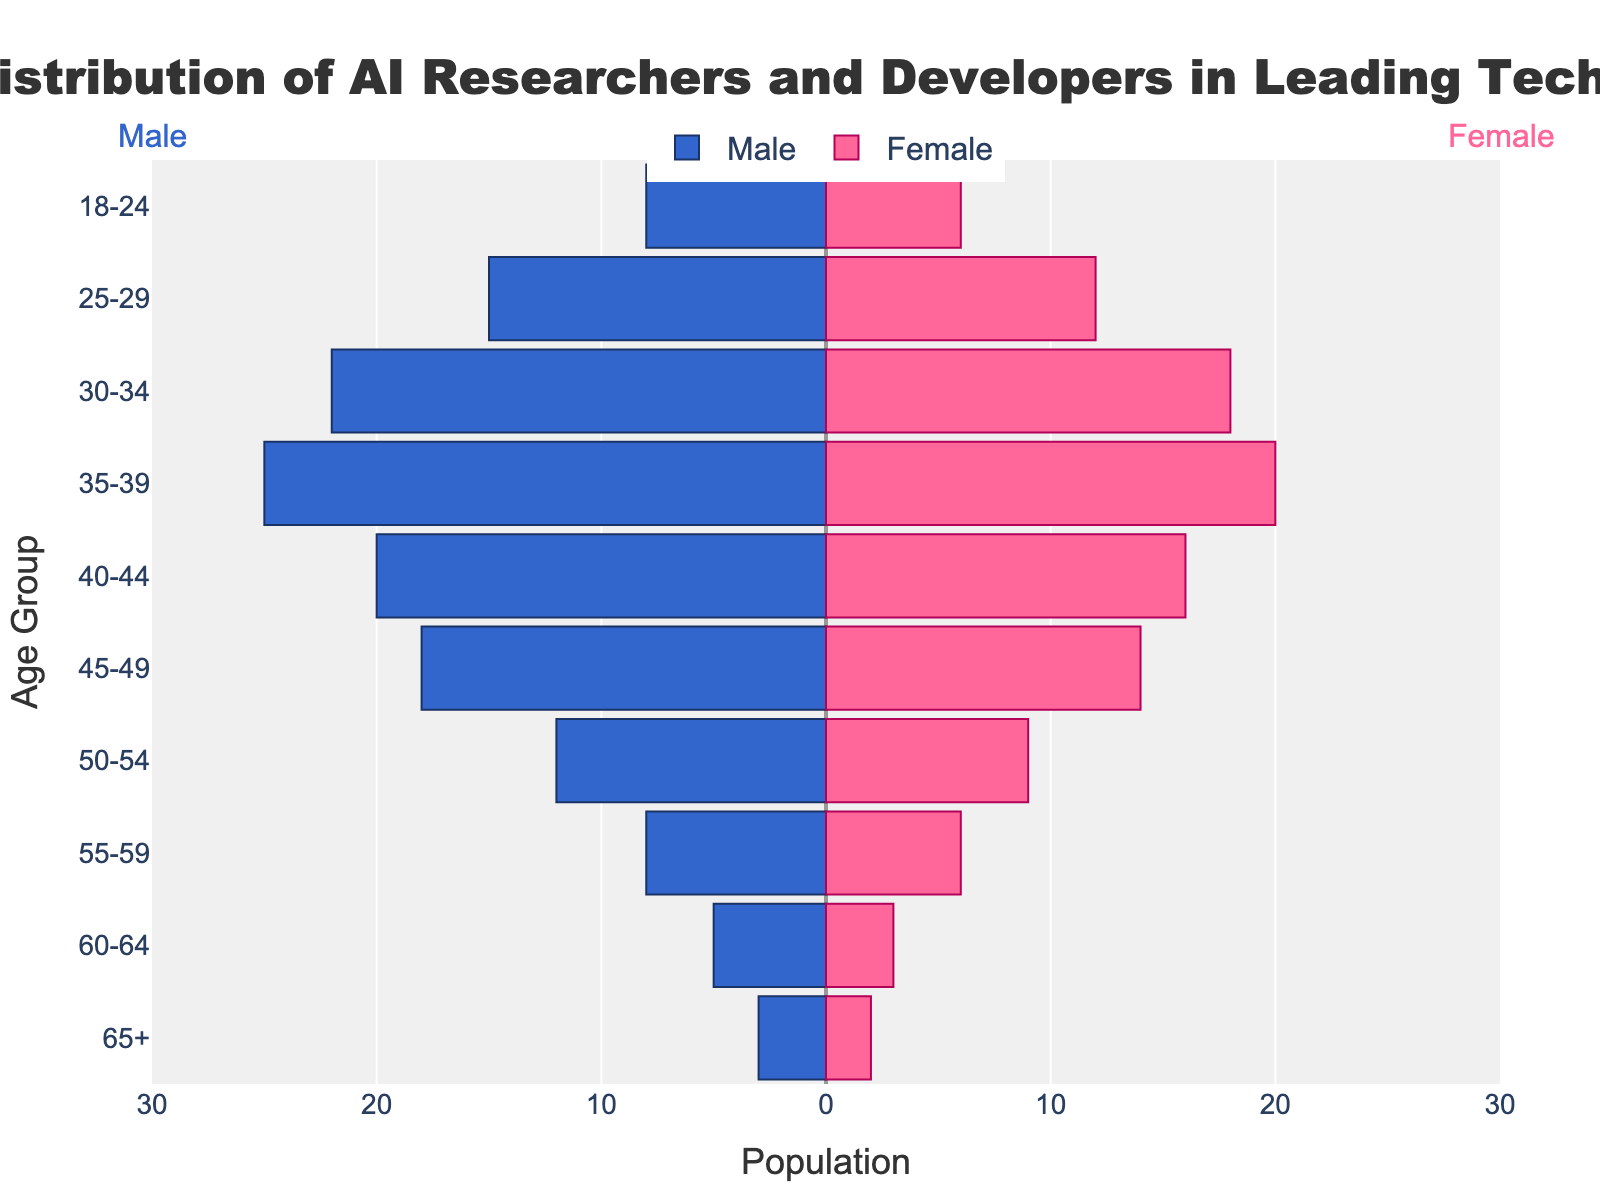What is the title of the figure? The title of the figure is prominently displayed at the top and it provides a summary of what the figure represents.
Answer: Age Distribution of AI Researchers and Developers in Leading Tech Hubs Which age group has the highest number of males? By looking at the length of the bars on the left side for each age group, the longest bar represents the age group with the highest number.
Answer: 35-39 How many females are there in the 25-29 age group? The bar on the right side for the 25-29 age group indicates the number of females.
Answer: 12 What is the difference between the number of males and females in the 40-44 age group? The number of males in the 40-44 age group is 20 and the number of females is 16. The difference is calculated as 20 - 16.
Answer: 4 Which gender has a higher population in the 55-59 age group, and by how much? The bar lengths for males and females in the 55-59 age group show that there are 8 males and 6 females. The difference can be found by 8 - 6.
Answer: Male, 2 What is the total population of AI researchers and developers in the 30-34 age group? The total population in the 30-34 age group is the sum of males and females: 22 males + 18 females.
Answer: 40 Is there an age group where the number of males and females are equal? By examining the bars' lengths for each age group, we can see if any pair of bars are equal in length.
Answer: No What can you infer about the trend in the male population as the age increases? By observing the pattern in the lengths of the bars on the left side from bottom (youngest) to top (oldest), a general trend can be identified.
Answer: The number of males generally decreases as age increases Which age group has the smallest total population, and what is the value? Smallest total population is determined by adding male and female values for each age group and finding the smallest sum. The smallest is 65+ with 3 males and 2 females.
Answer: 65+, 5 In which age group is the disparity between the number of males and females the greatest? The disparity is determined by calculating the absolute difference between males and females for each age group and selecting the largest difference. The greatest difference is in the 35-39 age group with 5.
Answer: 35-39 